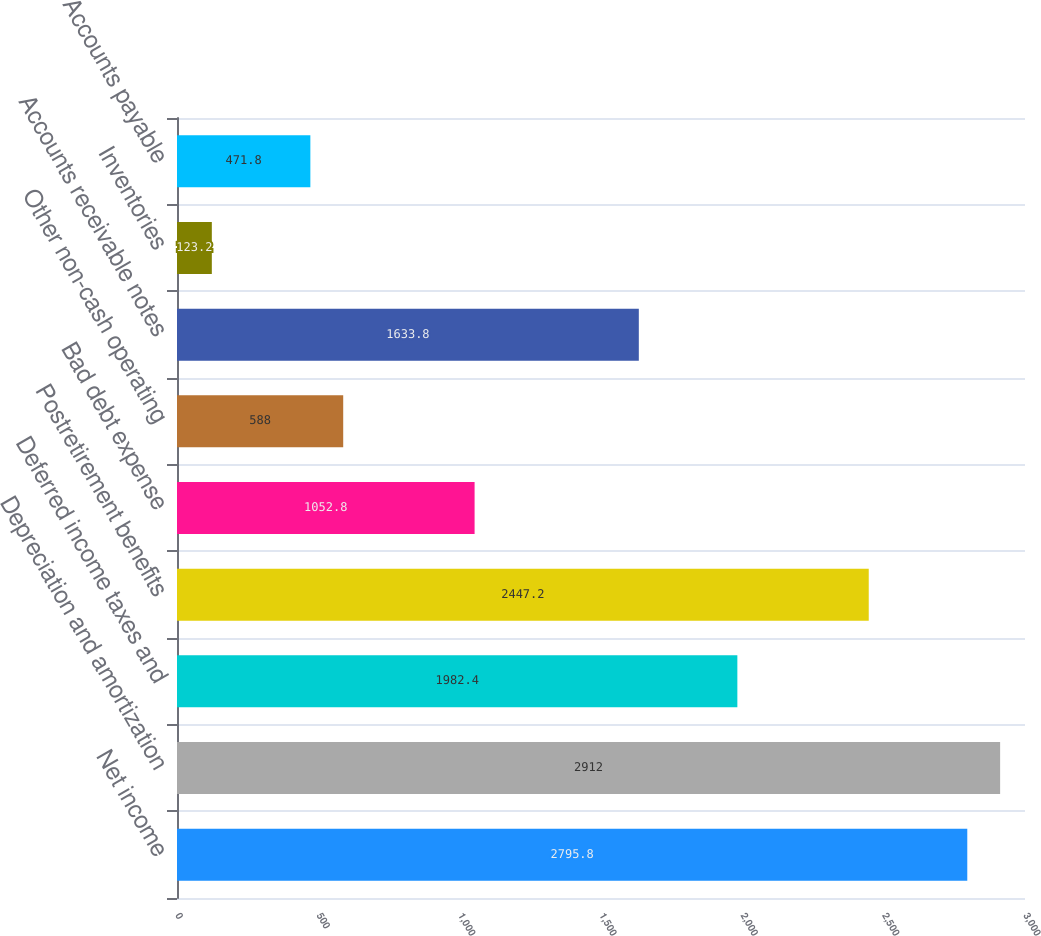<chart> <loc_0><loc_0><loc_500><loc_500><bar_chart><fcel>Net income<fcel>Depreciation and amortization<fcel>Deferred income taxes and<fcel>Postretirement benefits<fcel>Bad debt expense<fcel>Other non-cash operating<fcel>Accounts receivable notes<fcel>Inventories<fcel>Accounts payable<nl><fcel>2795.8<fcel>2912<fcel>1982.4<fcel>2447.2<fcel>1052.8<fcel>588<fcel>1633.8<fcel>123.2<fcel>471.8<nl></chart> 